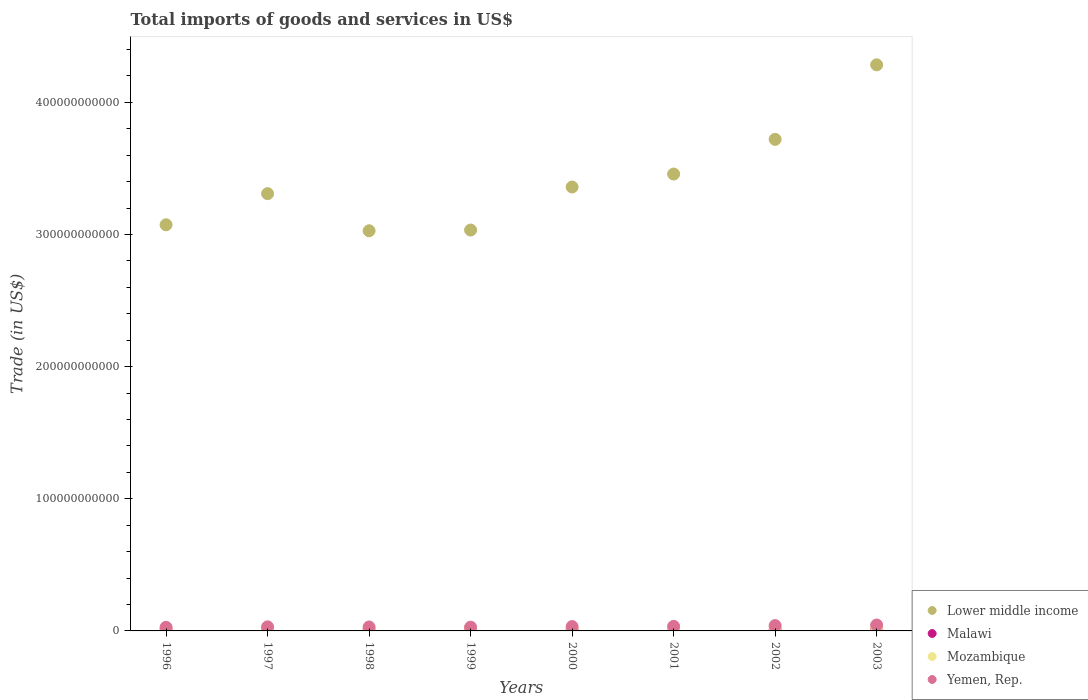Is the number of dotlines equal to the number of legend labels?
Your answer should be compact. Yes. What is the total imports of goods and services in Lower middle income in 1996?
Keep it short and to the point. 3.07e+11. Across all years, what is the maximum total imports of goods and services in Lower middle income?
Keep it short and to the point. 4.28e+11. Across all years, what is the minimum total imports of goods and services in Malawi?
Ensure brevity in your answer.  6.16e+08. In which year was the total imports of goods and services in Lower middle income minimum?
Provide a short and direct response. 1998. What is the total total imports of goods and services in Malawi in the graph?
Your answer should be compact. 6.24e+09. What is the difference between the total imports of goods and services in Mozambique in 1999 and that in 2002?
Your answer should be very brief. -7.22e+08. What is the difference between the total imports of goods and services in Mozambique in 2003 and the total imports of goods and services in Lower middle income in 1999?
Your answer should be very brief. -3.01e+11. What is the average total imports of goods and services in Lower middle income per year?
Give a very brief answer. 3.41e+11. In the year 1999, what is the difference between the total imports of goods and services in Yemen, Rep. and total imports of goods and services in Mozambique?
Keep it short and to the point. 7.44e+08. What is the ratio of the total imports of goods and services in Malawi in 2000 to that in 2001?
Your answer should be compact. 0.92. Is the total imports of goods and services in Yemen, Rep. in 1998 less than that in 2000?
Keep it short and to the point. Yes. What is the difference between the highest and the second highest total imports of goods and services in Mozambique?
Provide a succinct answer. 3.37e+07. What is the difference between the highest and the lowest total imports of goods and services in Malawi?
Provide a short and direct response. 3.68e+08. In how many years, is the total imports of goods and services in Lower middle income greater than the average total imports of goods and services in Lower middle income taken over all years?
Provide a succinct answer. 3. Is it the case that in every year, the sum of the total imports of goods and services in Mozambique and total imports of goods and services in Malawi  is greater than the total imports of goods and services in Lower middle income?
Your answer should be compact. No. Is the total imports of goods and services in Lower middle income strictly greater than the total imports of goods and services in Malawi over the years?
Your response must be concise. Yes. How many years are there in the graph?
Provide a short and direct response. 8. What is the difference between two consecutive major ticks on the Y-axis?
Provide a succinct answer. 1.00e+11. Does the graph contain grids?
Your response must be concise. No. Where does the legend appear in the graph?
Your answer should be compact. Bottom right. How many legend labels are there?
Keep it short and to the point. 4. How are the legend labels stacked?
Make the answer very short. Vertical. What is the title of the graph?
Your answer should be compact. Total imports of goods and services in US$. Does "Madagascar" appear as one of the legend labels in the graph?
Ensure brevity in your answer.  No. What is the label or title of the Y-axis?
Ensure brevity in your answer.  Trade (in US$). What is the Trade (in US$) of Lower middle income in 1996?
Make the answer very short. 3.07e+11. What is the Trade (in US$) of Malawi in 1996?
Keep it short and to the point. 7.27e+08. What is the Trade (in US$) of Mozambique in 1996?
Give a very brief answer. 1.43e+09. What is the Trade (in US$) of Yemen, Rep. in 1996?
Offer a very short reply. 2.74e+09. What is the Trade (in US$) of Lower middle income in 1997?
Offer a terse response. 3.31e+11. What is the Trade (in US$) in Malawi in 1997?
Offer a very short reply. 8.94e+08. What is the Trade (in US$) in Mozambique in 1997?
Your answer should be very brief. 1.44e+09. What is the Trade (in US$) of Yemen, Rep. in 1997?
Provide a succinct answer. 3.08e+09. What is the Trade (in US$) of Lower middle income in 1998?
Keep it short and to the point. 3.03e+11. What is the Trade (in US$) of Malawi in 1998?
Keep it short and to the point. 6.67e+08. What is the Trade (in US$) in Mozambique in 1998?
Your answer should be very brief. 1.47e+09. What is the Trade (in US$) of Yemen, Rep. in 1998?
Your answer should be very brief. 2.98e+09. What is the Trade (in US$) of Lower middle income in 1999?
Your response must be concise. 3.03e+11. What is the Trade (in US$) of Malawi in 1999?
Provide a succinct answer. 7.69e+08. What is the Trade (in US$) in Mozambique in 1999?
Your response must be concise. 2.10e+09. What is the Trade (in US$) in Yemen, Rep. in 1999?
Offer a terse response. 2.84e+09. What is the Trade (in US$) of Lower middle income in 2000?
Keep it short and to the point. 3.36e+11. What is the Trade (in US$) of Malawi in 2000?
Make the answer very short. 6.16e+08. What is the Trade (in US$) in Mozambique in 2000?
Keep it short and to the point. 1.98e+09. What is the Trade (in US$) in Yemen, Rep. in 2000?
Give a very brief answer. 3.28e+09. What is the Trade (in US$) in Lower middle income in 2001?
Offer a terse response. 3.46e+11. What is the Trade (in US$) in Malawi in 2001?
Provide a succinct answer. 6.72e+08. What is the Trade (in US$) in Mozambique in 2001?
Your answer should be compact. 1.64e+09. What is the Trade (in US$) of Yemen, Rep. in 2001?
Offer a very short reply. 3.45e+09. What is the Trade (in US$) of Lower middle income in 2002?
Provide a short and direct response. 3.72e+11. What is the Trade (in US$) of Malawi in 2002?
Ensure brevity in your answer.  9.10e+08. What is the Trade (in US$) of Mozambique in 2002?
Your response must be concise. 2.82e+09. What is the Trade (in US$) in Yemen, Rep. in 2002?
Your answer should be compact. 4.03e+09. What is the Trade (in US$) in Lower middle income in 2003?
Offer a terse response. 4.28e+11. What is the Trade (in US$) in Malawi in 2003?
Offer a very short reply. 9.84e+08. What is the Trade (in US$) in Mozambique in 2003?
Offer a terse response. 2.85e+09. What is the Trade (in US$) in Yemen, Rep. in 2003?
Your answer should be very brief. 4.47e+09. Across all years, what is the maximum Trade (in US$) in Lower middle income?
Your answer should be compact. 4.28e+11. Across all years, what is the maximum Trade (in US$) in Malawi?
Make the answer very short. 9.84e+08. Across all years, what is the maximum Trade (in US$) of Mozambique?
Make the answer very short. 2.85e+09. Across all years, what is the maximum Trade (in US$) of Yemen, Rep.?
Keep it short and to the point. 4.47e+09. Across all years, what is the minimum Trade (in US$) of Lower middle income?
Your response must be concise. 3.03e+11. Across all years, what is the minimum Trade (in US$) in Malawi?
Give a very brief answer. 6.16e+08. Across all years, what is the minimum Trade (in US$) of Mozambique?
Ensure brevity in your answer.  1.43e+09. Across all years, what is the minimum Trade (in US$) of Yemen, Rep.?
Offer a terse response. 2.74e+09. What is the total Trade (in US$) of Lower middle income in the graph?
Your answer should be very brief. 2.73e+12. What is the total Trade (in US$) in Malawi in the graph?
Your response must be concise. 6.24e+09. What is the total Trade (in US$) of Mozambique in the graph?
Provide a succinct answer. 1.57e+1. What is the total Trade (in US$) in Yemen, Rep. in the graph?
Give a very brief answer. 2.69e+1. What is the difference between the Trade (in US$) in Lower middle income in 1996 and that in 1997?
Make the answer very short. -2.36e+1. What is the difference between the Trade (in US$) of Malawi in 1996 and that in 1997?
Provide a succinct answer. -1.67e+08. What is the difference between the Trade (in US$) of Mozambique in 1996 and that in 1997?
Your answer should be very brief. -1.18e+07. What is the difference between the Trade (in US$) in Yemen, Rep. in 1996 and that in 1997?
Make the answer very short. -3.40e+08. What is the difference between the Trade (in US$) of Lower middle income in 1996 and that in 1998?
Offer a terse response. 4.52e+09. What is the difference between the Trade (in US$) of Malawi in 1996 and that in 1998?
Keep it short and to the point. 6.01e+07. What is the difference between the Trade (in US$) of Mozambique in 1996 and that in 1998?
Your answer should be very brief. -4.30e+07. What is the difference between the Trade (in US$) in Yemen, Rep. in 1996 and that in 1998?
Offer a very short reply. -2.39e+08. What is the difference between the Trade (in US$) of Lower middle income in 1996 and that in 1999?
Your answer should be compact. 3.98e+09. What is the difference between the Trade (in US$) of Malawi in 1996 and that in 1999?
Give a very brief answer. -4.17e+07. What is the difference between the Trade (in US$) of Mozambique in 1996 and that in 1999?
Your answer should be compact. -6.67e+08. What is the difference between the Trade (in US$) in Yemen, Rep. in 1996 and that in 1999?
Provide a short and direct response. -9.55e+07. What is the difference between the Trade (in US$) in Lower middle income in 1996 and that in 2000?
Ensure brevity in your answer.  -2.86e+1. What is the difference between the Trade (in US$) of Malawi in 1996 and that in 2000?
Offer a very short reply. 1.11e+08. What is the difference between the Trade (in US$) of Mozambique in 1996 and that in 2000?
Offer a very short reply. -5.56e+08. What is the difference between the Trade (in US$) in Yemen, Rep. in 1996 and that in 2000?
Provide a succinct answer. -5.35e+08. What is the difference between the Trade (in US$) in Lower middle income in 1996 and that in 2001?
Provide a short and direct response. -3.84e+1. What is the difference between the Trade (in US$) in Malawi in 1996 and that in 2001?
Your response must be concise. 5.55e+07. What is the difference between the Trade (in US$) of Mozambique in 1996 and that in 2001?
Your answer should be very brief. -2.06e+08. What is the difference between the Trade (in US$) of Yemen, Rep. in 1996 and that in 2001?
Your answer should be compact. -7.04e+08. What is the difference between the Trade (in US$) of Lower middle income in 1996 and that in 2002?
Keep it short and to the point. -6.47e+1. What is the difference between the Trade (in US$) of Malawi in 1996 and that in 2002?
Provide a short and direct response. -1.83e+08. What is the difference between the Trade (in US$) in Mozambique in 1996 and that in 2002?
Your answer should be very brief. -1.39e+09. What is the difference between the Trade (in US$) in Yemen, Rep. in 1996 and that in 2002?
Your response must be concise. -1.29e+09. What is the difference between the Trade (in US$) in Lower middle income in 1996 and that in 2003?
Offer a terse response. -1.21e+11. What is the difference between the Trade (in US$) of Malawi in 1996 and that in 2003?
Give a very brief answer. -2.57e+08. What is the difference between the Trade (in US$) of Mozambique in 1996 and that in 2003?
Ensure brevity in your answer.  -1.42e+09. What is the difference between the Trade (in US$) of Yemen, Rep. in 1996 and that in 2003?
Provide a succinct answer. -1.72e+09. What is the difference between the Trade (in US$) of Lower middle income in 1997 and that in 1998?
Your answer should be very brief. 2.81e+1. What is the difference between the Trade (in US$) of Malawi in 1997 and that in 1998?
Ensure brevity in your answer.  2.27e+08. What is the difference between the Trade (in US$) of Mozambique in 1997 and that in 1998?
Offer a terse response. -3.12e+07. What is the difference between the Trade (in US$) of Yemen, Rep. in 1997 and that in 1998?
Your response must be concise. 1.01e+08. What is the difference between the Trade (in US$) in Lower middle income in 1997 and that in 1999?
Make the answer very short. 2.75e+1. What is the difference between the Trade (in US$) of Malawi in 1997 and that in 1999?
Your answer should be compact. 1.26e+08. What is the difference between the Trade (in US$) of Mozambique in 1997 and that in 1999?
Provide a short and direct response. -6.55e+08. What is the difference between the Trade (in US$) in Yemen, Rep. in 1997 and that in 1999?
Provide a short and direct response. 2.44e+08. What is the difference between the Trade (in US$) in Lower middle income in 1997 and that in 2000?
Your answer should be very brief. -5.03e+09. What is the difference between the Trade (in US$) in Malawi in 1997 and that in 2000?
Offer a very short reply. 2.78e+08. What is the difference between the Trade (in US$) in Mozambique in 1997 and that in 2000?
Your answer should be compact. -5.44e+08. What is the difference between the Trade (in US$) in Yemen, Rep. in 1997 and that in 2000?
Ensure brevity in your answer.  -1.95e+08. What is the difference between the Trade (in US$) of Lower middle income in 1997 and that in 2001?
Give a very brief answer. -1.49e+1. What is the difference between the Trade (in US$) in Malawi in 1997 and that in 2001?
Offer a very short reply. 2.23e+08. What is the difference between the Trade (in US$) in Mozambique in 1997 and that in 2001?
Your response must be concise. -1.95e+08. What is the difference between the Trade (in US$) of Yemen, Rep. in 1997 and that in 2001?
Your answer should be compact. -3.64e+08. What is the difference between the Trade (in US$) of Lower middle income in 1997 and that in 2002?
Provide a succinct answer. -4.11e+1. What is the difference between the Trade (in US$) of Malawi in 1997 and that in 2002?
Ensure brevity in your answer.  -1.58e+07. What is the difference between the Trade (in US$) in Mozambique in 1997 and that in 2002?
Give a very brief answer. -1.38e+09. What is the difference between the Trade (in US$) in Yemen, Rep. in 1997 and that in 2002?
Give a very brief answer. -9.50e+08. What is the difference between the Trade (in US$) of Lower middle income in 1997 and that in 2003?
Give a very brief answer. -9.75e+1. What is the difference between the Trade (in US$) of Malawi in 1997 and that in 2003?
Ensure brevity in your answer.  -8.99e+07. What is the difference between the Trade (in US$) in Mozambique in 1997 and that in 2003?
Make the answer very short. -1.41e+09. What is the difference between the Trade (in US$) of Yemen, Rep. in 1997 and that in 2003?
Make the answer very short. -1.38e+09. What is the difference between the Trade (in US$) in Lower middle income in 1998 and that in 1999?
Your response must be concise. -5.44e+08. What is the difference between the Trade (in US$) of Malawi in 1998 and that in 1999?
Give a very brief answer. -1.02e+08. What is the difference between the Trade (in US$) of Mozambique in 1998 and that in 1999?
Offer a very short reply. -6.24e+08. What is the difference between the Trade (in US$) in Yemen, Rep. in 1998 and that in 1999?
Ensure brevity in your answer.  1.43e+08. What is the difference between the Trade (in US$) in Lower middle income in 1998 and that in 2000?
Your response must be concise. -3.31e+1. What is the difference between the Trade (in US$) in Malawi in 1998 and that in 2000?
Offer a very short reply. 5.10e+07. What is the difference between the Trade (in US$) of Mozambique in 1998 and that in 2000?
Your response must be concise. -5.13e+08. What is the difference between the Trade (in US$) in Yemen, Rep. in 1998 and that in 2000?
Your answer should be compact. -2.96e+08. What is the difference between the Trade (in US$) of Lower middle income in 1998 and that in 2001?
Provide a short and direct response. -4.29e+1. What is the difference between the Trade (in US$) of Malawi in 1998 and that in 2001?
Offer a terse response. -4.56e+06. What is the difference between the Trade (in US$) of Mozambique in 1998 and that in 2001?
Give a very brief answer. -1.63e+08. What is the difference between the Trade (in US$) of Yemen, Rep. in 1998 and that in 2001?
Offer a very short reply. -4.65e+08. What is the difference between the Trade (in US$) in Lower middle income in 1998 and that in 2002?
Your answer should be compact. -6.92e+1. What is the difference between the Trade (in US$) of Malawi in 1998 and that in 2002?
Provide a short and direct response. -2.43e+08. What is the difference between the Trade (in US$) in Mozambique in 1998 and that in 2002?
Your response must be concise. -1.35e+09. What is the difference between the Trade (in US$) of Yemen, Rep. in 1998 and that in 2002?
Make the answer very short. -1.05e+09. What is the difference between the Trade (in US$) of Lower middle income in 1998 and that in 2003?
Provide a succinct answer. -1.26e+11. What is the difference between the Trade (in US$) in Malawi in 1998 and that in 2003?
Ensure brevity in your answer.  -3.17e+08. What is the difference between the Trade (in US$) in Mozambique in 1998 and that in 2003?
Your answer should be very brief. -1.38e+09. What is the difference between the Trade (in US$) in Yemen, Rep. in 1998 and that in 2003?
Your response must be concise. -1.49e+09. What is the difference between the Trade (in US$) in Lower middle income in 1999 and that in 2000?
Make the answer very short. -3.26e+1. What is the difference between the Trade (in US$) in Malawi in 1999 and that in 2000?
Your answer should be very brief. 1.53e+08. What is the difference between the Trade (in US$) of Mozambique in 1999 and that in 2000?
Ensure brevity in your answer.  1.11e+08. What is the difference between the Trade (in US$) in Yemen, Rep. in 1999 and that in 2000?
Offer a very short reply. -4.39e+08. What is the difference between the Trade (in US$) of Lower middle income in 1999 and that in 2001?
Your answer should be compact. -4.24e+1. What is the difference between the Trade (in US$) in Malawi in 1999 and that in 2001?
Make the answer very short. 9.72e+07. What is the difference between the Trade (in US$) of Mozambique in 1999 and that in 2001?
Offer a very short reply. 4.60e+08. What is the difference between the Trade (in US$) of Yemen, Rep. in 1999 and that in 2001?
Provide a short and direct response. -6.09e+08. What is the difference between the Trade (in US$) in Lower middle income in 1999 and that in 2002?
Provide a short and direct response. -6.86e+1. What is the difference between the Trade (in US$) of Malawi in 1999 and that in 2002?
Make the answer very short. -1.41e+08. What is the difference between the Trade (in US$) in Mozambique in 1999 and that in 2002?
Give a very brief answer. -7.22e+08. What is the difference between the Trade (in US$) in Yemen, Rep. in 1999 and that in 2002?
Your answer should be compact. -1.19e+09. What is the difference between the Trade (in US$) of Lower middle income in 1999 and that in 2003?
Make the answer very short. -1.25e+11. What is the difference between the Trade (in US$) in Malawi in 1999 and that in 2003?
Your answer should be compact. -2.15e+08. What is the difference between the Trade (in US$) of Mozambique in 1999 and that in 2003?
Provide a short and direct response. -7.56e+08. What is the difference between the Trade (in US$) of Yemen, Rep. in 1999 and that in 2003?
Provide a succinct answer. -1.63e+09. What is the difference between the Trade (in US$) in Lower middle income in 2000 and that in 2001?
Your answer should be compact. -9.82e+09. What is the difference between the Trade (in US$) of Malawi in 2000 and that in 2001?
Offer a terse response. -5.56e+07. What is the difference between the Trade (in US$) in Mozambique in 2000 and that in 2001?
Make the answer very short. 3.50e+08. What is the difference between the Trade (in US$) of Yemen, Rep. in 2000 and that in 2001?
Your answer should be compact. -1.69e+08. What is the difference between the Trade (in US$) in Lower middle income in 2000 and that in 2002?
Give a very brief answer. -3.61e+1. What is the difference between the Trade (in US$) of Malawi in 2000 and that in 2002?
Provide a succinct answer. -2.94e+08. What is the difference between the Trade (in US$) in Mozambique in 2000 and that in 2002?
Your answer should be compact. -8.33e+08. What is the difference between the Trade (in US$) of Yemen, Rep. in 2000 and that in 2002?
Provide a short and direct response. -7.55e+08. What is the difference between the Trade (in US$) of Lower middle income in 2000 and that in 2003?
Offer a terse response. -9.25e+1. What is the difference between the Trade (in US$) in Malawi in 2000 and that in 2003?
Make the answer very short. -3.68e+08. What is the difference between the Trade (in US$) of Mozambique in 2000 and that in 2003?
Provide a succinct answer. -8.67e+08. What is the difference between the Trade (in US$) of Yemen, Rep. in 2000 and that in 2003?
Make the answer very short. -1.19e+09. What is the difference between the Trade (in US$) in Lower middle income in 2001 and that in 2002?
Offer a terse response. -2.62e+1. What is the difference between the Trade (in US$) in Malawi in 2001 and that in 2002?
Your response must be concise. -2.39e+08. What is the difference between the Trade (in US$) of Mozambique in 2001 and that in 2002?
Offer a very short reply. -1.18e+09. What is the difference between the Trade (in US$) in Yemen, Rep. in 2001 and that in 2002?
Your answer should be compact. -5.86e+08. What is the difference between the Trade (in US$) of Lower middle income in 2001 and that in 2003?
Provide a short and direct response. -8.26e+1. What is the difference between the Trade (in US$) of Malawi in 2001 and that in 2003?
Keep it short and to the point. -3.13e+08. What is the difference between the Trade (in US$) in Mozambique in 2001 and that in 2003?
Offer a terse response. -1.22e+09. What is the difference between the Trade (in US$) in Yemen, Rep. in 2001 and that in 2003?
Your response must be concise. -1.02e+09. What is the difference between the Trade (in US$) in Lower middle income in 2002 and that in 2003?
Make the answer very short. -5.64e+1. What is the difference between the Trade (in US$) of Malawi in 2002 and that in 2003?
Offer a very short reply. -7.41e+07. What is the difference between the Trade (in US$) in Mozambique in 2002 and that in 2003?
Give a very brief answer. -3.37e+07. What is the difference between the Trade (in US$) in Yemen, Rep. in 2002 and that in 2003?
Give a very brief answer. -4.34e+08. What is the difference between the Trade (in US$) in Lower middle income in 1996 and the Trade (in US$) in Malawi in 1997?
Offer a terse response. 3.06e+11. What is the difference between the Trade (in US$) in Lower middle income in 1996 and the Trade (in US$) in Mozambique in 1997?
Your answer should be very brief. 3.06e+11. What is the difference between the Trade (in US$) of Lower middle income in 1996 and the Trade (in US$) of Yemen, Rep. in 1997?
Give a very brief answer. 3.04e+11. What is the difference between the Trade (in US$) of Malawi in 1996 and the Trade (in US$) of Mozambique in 1997?
Keep it short and to the point. -7.13e+08. What is the difference between the Trade (in US$) of Malawi in 1996 and the Trade (in US$) of Yemen, Rep. in 1997?
Provide a succinct answer. -2.36e+09. What is the difference between the Trade (in US$) of Mozambique in 1996 and the Trade (in US$) of Yemen, Rep. in 1997?
Make the answer very short. -1.66e+09. What is the difference between the Trade (in US$) in Lower middle income in 1996 and the Trade (in US$) in Malawi in 1998?
Your answer should be very brief. 3.07e+11. What is the difference between the Trade (in US$) of Lower middle income in 1996 and the Trade (in US$) of Mozambique in 1998?
Your answer should be very brief. 3.06e+11. What is the difference between the Trade (in US$) in Lower middle income in 1996 and the Trade (in US$) in Yemen, Rep. in 1998?
Ensure brevity in your answer.  3.04e+11. What is the difference between the Trade (in US$) in Malawi in 1996 and the Trade (in US$) in Mozambique in 1998?
Your response must be concise. -7.45e+08. What is the difference between the Trade (in US$) of Malawi in 1996 and the Trade (in US$) of Yemen, Rep. in 1998?
Your response must be concise. -2.26e+09. What is the difference between the Trade (in US$) in Mozambique in 1996 and the Trade (in US$) in Yemen, Rep. in 1998?
Make the answer very short. -1.55e+09. What is the difference between the Trade (in US$) of Lower middle income in 1996 and the Trade (in US$) of Malawi in 1999?
Provide a short and direct response. 3.07e+11. What is the difference between the Trade (in US$) in Lower middle income in 1996 and the Trade (in US$) in Mozambique in 1999?
Provide a succinct answer. 3.05e+11. What is the difference between the Trade (in US$) in Lower middle income in 1996 and the Trade (in US$) in Yemen, Rep. in 1999?
Make the answer very short. 3.05e+11. What is the difference between the Trade (in US$) in Malawi in 1996 and the Trade (in US$) in Mozambique in 1999?
Ensure brevity in your answer.  -1.37e+09. What is the difference between the Trade (in US$) of Malawi in 1996 and the Trade (in US$) of Yemen, Rep. in 1999?
Offer a terse response. -2.11e+09. What is the difference between the Trade (in US$) in Mozambique in 1996 and the Trade (in US$) in Yemen, Rep. in 1999?
Offer a terse response. -1.41e+09. What is the difference between the Trade (in US$) in Lower middle income in 1996 and the Trade (in US$) in Malawi in 2000?
Make the answer very short. 3.07e+11. What is the difference between the Trade (in US$) of Lower middle income in 1996 and the Trade (in US$) of Mozambique in 2000?
Offer a very short reply. 3.05e+11. What is the difference between the Trade (in US$) of Lower middle income in 1996 and the Trade (in US$) of Yemen, Rep. in 2000?
Your answer should be very brief. 3.04e+11. What is the difference between the Trade (in US$) in Malawi in 1996 and the Trade (in US$) in Mozambique in 2000?
Give a very brief answer. -1.26e+09. What is the difference between the Trade (in US$) of Malawi in 1996 and the Trade (in US$) of Yemen, Rep. in 2000?
Offer a very short reply. -2.55e+09. What is the difference between the Trade (in US$) in Mozambique in 1996 and the Trade (in US$) in Yemen, Rep. in 2000?
Your response must be concise. -1.85e+09. What is the difference between the Trade (in US$) in Lower middle income in 1996 and the Trade (in US$) in Malawi in 2001?
Your response must be concise. 3.07e+11. What is the difference between the Trade (in US$) of Lower middle income in 1996 and the Trade (in US$) of Mozambique in 2001?
Ensure brevity in your answer.  3.06e+11. What is the difference between the Trade (in US$) in Lower middle income in 1996 and the Trade (in US$) in Yemen, Rep. in 2001?
Your answer should be very brief. 3.04e+11. What is the difference between the Trade (in US$) of Malawi in 1996 and the Trade (in US$) of Mozambique in 2001?
Provide a short and direct response. -9.08e+08. What is the difference between the Trade (in US$) in Malawi in 1996 and the Trade (in US$) in Yemen, Rep. in 2001?
Keep it short and to the point. -2.72e+09. What is the difference between the Trade (in US$) in Mozambique in 1996 and the Trade (in US$) in Yemen, Rep. in 2001?
Your answer should be very brief. -2.02e+09. What is the difference between the Trade (in US$) in Lower middle income in 1996 and the Trade (in US$) in Malawi in 2002?
Your response must be concise. 3.06e+11. What is the difference between the Trade (in US$) in Lower middle income in 1996 and the Trade (in US$) in Mozambique in 2002?
Your answer should be very brief. 3.05e+11. What is the difference between the Trade (in US$) of Lower middle income in 1996 and the Trade (in US$) of Yemen, Rep. in 2002?
Offer a very short reply. 3.03e+11. What is the difference between the Trade (in US$) in Malawi in 1996 and the Trade (in US$) in Mozambique in 2002?
Ensure brevity in your answer.  -2.09e+09. What is the difference between the Trade (in US$) in Malawi in 1996 and the Trade (in US$) in Yemen, Rep. in 2002?
Offer a terse response. -3.31e+09. What is the difference between the Trade (in US$) of Mozambique in 1996 and the Trade (in US$) of Yemen, Rep. in 2002?
Offer a terse response. -2.61e+09. What is the difference between the Trade (in US$) in Lower middle income in 1996 and the Trade (in US$) in Malawi in 2003?
Your answer should be very brief. 3.06e+11. What is the difference between the Trade (in US$) in Lower middle income in 1996 and the Trade (in US$) in Mozambique in 2003?
Your answer should be very brief. 3.04e+11. What is the difference between the Trade (in US$) in Lower middle income in 1996 and the Trade (in US$) in Yemen, Rep. in 2003?
Give a very brief answer. 3.03e+11. What is the difference between the Trade (in US$) of Malawi in 1996 and the Trade (in US$) of Mozambique in 2003?
Offer a terse response. -2.12e+09. What is the difference between the Trade (in US$) in Malawi in 1996 and the Trade (in US$) in Yemen, Rep. in 2003?
Provide a short and direct response. -3.74e+09. What is the difference between the Trade (in US$) of Mozambique in 1996 and the Trade (in US$) of Yemen, Rep. in 2003?
Make the answer very short. -3.04e+09. What is the difference between the Trade (in US$) of Lower middle income in 1997 and the Trade (in US$) of Malawi in 1998?
Offer a very short reply. 3.30e+11. What is the difference between the Trade (in US$) in Lower middle income in 1997 and the Trade (in US$) in Mozambique in 1998?
Your answer should be very brief. 3.29e+11. What is the difference between the Trade (in US$) of Lower middle income in 1997 and the Trade (in US$) of Yemen, Rep. in 1998?
Your response must be concise. 3.28e+11. What is the difference between the Trade (in US$) in Malawi in 1997 and the Trade (in US$) in Mozambique in 1998?
Give a very brief answer. -5.77e+08. What is the difference between the Trade (in US$) in Malawi in 1997 and the Trade (in US$) in Yemen, Rep. in 1998?
Keep it short and to the point. -2.09e+09. What is the difference between the Trade (in US$) of Mozambique in 1997 and the Trade (in US$) of Yemen, Rep. in 1998?
Your response must be concise. -1.54e+09. What is the difference between the Trade (in US$) of Lower middle income in 1997 and the Trade (in US$) of Malawi in 1999?
Keep it short and to the point. 3.30e+11. What is the difference between the Trade (in US$) of Lower middle income in 1997 and the Trade (in US$) of Mozambique in 1999?
Provide a short and direct response. 3.29e+11. What is the difference between the Trade (in US$) in Lower middle income in 1997 and the Trade (in US$) in Yemen, Rep. in 1999?
Offer a very short reply. 3.28e+11. What is the difference between the Trade (in US$) of Malawi in 1997 and the Trade (in US$) of Mozambique in 1999?
Offer a very short reply. -1.20e+09. What is the difference between the Trade (in US$) of Malawi in 1997 and the Trade (in US$) of Yemen, Rep. in 1999?
Offer a very short reply. -1.95e+09. What is the difference between the Trade (in US$) in Mozambique in 1997 and the Trade (in US$) in Yemen, Rep. in 1999?
Your answer should be compact. -1.40e+09. What is the difference between the Trade (in US$) of Lower middle income in 1997 and the Trade (in US$) of Malawi in 2000?
Keep it short and to the point. 3.30e+11. What is the difference between the Trade (in US$) in Lower middle income in 1997 and the Trade (in US$) in Mozambique in 2000?
Your answer should be compact. 3.29e+11. What is the difference between the Trade (in US$) in Lower middle income in 1997 and the Trade (in US$) in Yemen, Rep. in 2000?
Offer a very short reply. 3.28e+11. What is the difference between the Trade (in US$) of Malawi in 1997 and the Trade (in US$) of Mozambique in 2000?
Your answer should be very brief. -1.09e+09. What is the difference between the Trade (in US$) of Malawi in 1997 and the Trade (in US$) of Yemen, Rep. in 2000?
Offer a terse response. -2.38e+09. What is the difference between the Trade (in US$) in Mozambique in 1997 and the Trade (in US$) in Yemen, Rep. in 2000?
Give a very brief answer. -1.84e+09. What is the difference between the Trade (in US$) of Lower middle income in 1997 and the Trade (in US$) of Malawi in 2001?
Your answer should be very brief. 3.30e+11. What is the difference between the Trade (in US$) of Lower middle income in 1997 and the Trade (in US$) of Mozambique in 2001?
Make the answer very short. 3.29e+11. What is the difference between the Trade (in US$) in Lower middle income in 1997 and the Trade (in US$) in Yemen, Rep. in 2001?
Your answer should be very brief. 3.27e+11. What is the difference between the Trade (in US$) in Malawi in 1997 and the Trade (in US$) in Mozambique in 2001?
Provide a short and direct response. -7.41e+08. What is the difference between the Trade (in US$) in Malawi in 1997 and the Trade (in US$) in Yemen, Rep. in 2001?
Your response must be concise. -2.55e+09. What is the difference between the Trade (in US$) of Mozambique in 1997 and the Trade (in US$) of Yemen, Rep. in 2001?
Provide a succinct answer. -2.01e+09. What is the difference between the Trade (in US$) in Lower middle income in 1997 and the Trade (in US$) in Malawi in 2002?
Provide a succinct answer. 3.30e+11. What is the difference between the Trade (in US$) of Lower middle income in 1997 and the Trade (in US$) of Mozambique in 2002?
Make the answer very short. 3.28e+11. What is the difference between the Trade (in US$) in Lower middle income in 1997 and the Trade (in US$) in Yemen, Rep. in 2002?
Give a very brief answer. 3.27e+11. What is the difference between the Trade (in US$) in Malawi in 1997 and the Trade (in US$) in Mozambique in 2002?
Keep it short and to the point. -1.92e+09. What is the difference between the Trade (in US$) of Malawi in 1997 and the Trade (in US$) of Yemen, Rep. in 2002?
Your response must be concise. -3.14e+09. What is the difference between the Trade (in US$) in Mozambique in 1997 and the Trade (in US$) in Yemen, Rep. in 2002?
Make the answer very short. -2.59e+09. What is the difference between the Trade (in US$) in Lower middle income in 1997 and the Trade (in US$) in Malawi in 2003?
Provide a succinct answer. 3.30e+11. What is the difference between the Trade (in US$) in Lower middle income in 1997 and the Trade (in US$) in Mozambique in 2003?
Ensure brevity in your answer.  3.28e+11. What is the difference between the Trade (in US$) in Lower middle income in 1997 and the Trade (in US$) in Yemen, Rep. in 2003?
Provide a short and direct response. 3.26e+11. What is the difference between the Trade (in US$) in Malawi in 1997 and the Trade (in US$) in Mozambique in 2003?
Offer a terse response. -1.96e+09. What is the difference between the Trade (in US$) in Malawi in 1997 and the Trade (in US$) in Yemen, Rep. in 2003?
Ensure brevity in your answer.  -3.57e+09. What is the difference between the Trade (in US$) in Mozambique in 1997 and the Trade (in US$) in Yemen, Rep. in 2003?
Give a very brief answer. -3.03e+09. What is the difference between the Trade (in US$) of Lower middle income in 1998 and the Trade (in US$) of Malawi in 1999?
Offer a very short reply. 3.02e+11. What is the difference between the Trade (in US$) in Lower middle income in 1998 and the Trade (in US$) in Mozambique in 1999?
Keep it short and to the point. 3.01e+11. What is the difference between the Trade (in US$) in Lower middle income in 1998 and the Trade (in US$) in Yemen, Rep. in 1999?
Ensure brevity in your answer.  3.00e+11. What is the difference between the Trade (in US$) in Malawi in 1998 and the Trade (in US$) in Mozambique in 1999?
Keep it short and to the point. -1.43e+09. What is the difference between the Trade (in US$) of Malawi in 1998 and the Trade (in US$) of Yemen, Rep. in 1999?
Offer a terse response. -2.17e+09. What is the difference between the Trade (in US$) of Mozambique in 1998 and the Trade (in US$) of Yemen, Rep. in 1999?
Your response must be concise. -1.37e+09. What is the difference between the Trade (in US$) in Lower middle income in 1998 and the Trade (in US$) in Malawi in 2000?
Provide a succinct answer. 3.02e+11. What is the difference between the Trade (in US$) of Lower middle income in 1998 and the Trade (in US$) of Mozambique in 2000?
Make the answer very short. 3.01e+11. What is the difference between the Trade (in US$) of Lower middle income in 1998 and the Trade (in US$) of Yemen, Rep. in 2000?
Your response must be concise. 3.00e+11. What is the difference between the Trade (in US$) in Malawi in 1998 and the Trade (in US$) in Mozambique in 2000?
Your answer should be very brief. -1.32e+09. What is the difference between the Trade (in US$) in Malawi in 1998 and the Trade (in US$) in Yemen, Rep. in 2000?
Your answer should be very brief. -2.61e+09. What is the difference between the Trade (in US$) in Mozambique in 1998 and the Trade (in US$) in Yemen, Rep. in 2000?
Offer a very short reply. -1.81e+09. What is the difference between the Trade (in US$) in Lower middle income in 1998 and the Trade (in US$) in Malawi in 2001?
Your response must be concise. 3.02e+11. What is the difference between the Trade (in US$) of Lower middle income in 1998 and the Trade (in US$) of Mozambique in 2001?
Offer a terse response. 3.01e+11. What is the difference between the Trade (in US$) of Lower middle income in 1998 and the Trade (in US$) of Yemen, Rep. in 2001?
Provide a short and direct response. 2.99e+11. What is the difference between the Trade (in US$) in Malawi in 1998 and the Trade (in US$) in Mozambique in 2001?
Provide a short and direct response. -9.68e+08. What is the difference between the Trade (in US$) in Malawi in 1998 and the Trade (in US$) in Yemen, Rep. in 2001?
Your answer should be compact. -2.78e+09. What is the difference between the Trade (in US$) in Mozambique in 1998 and the Trade (in US$) in Yemen, Rep. in 2001?
Provide a short and direct response. -1.98e+09. What is the difference between the Trade (in US$) of Lower middle income in 1998 and the Trade (in US$) of Malawi in 2002?
Offer a very short reply. 3.02e+11. What is the difference between the Trade (in US$) of Lower middle income in 1998 and the Trade (in US$) of Mozambique in 2002?
Your response must be concise. 3.00e+11. What is the difference between the Trade (in US$) of Lower middle income in 1998 and the Trade (in US$) of Yemen, Rep. in 2002?
Make the answer very short. 2.99e+11. What is the difference between the Trade (in US$) in Malawi in 1998 and the Trade (in US$) in Mozambique in 2002?
Provide a short and direct response. -2.15e+09. What is the difference between the Trade (in US$) in Malawi in 1998 and the Trade (in US$) in Yemen, Rep. in 2002?
Offer a very short reply. -3.37e+09. What is the difference between the Trade (in US$) of Mozambique in 1998 and the Trade (in US$) of Yemen, Rep. in 2002?
Your answer should be compact. -2.56e+09. What is the difference between the Trade (in US$) in Lower middle income in 1998 and the Trade (in US$) in Malawi in 2003?
Keep it short and to the point. 3.02e+11. What is the difference between the Trade (in US$) in Lower middle income in 1998 and the Trade (in US$) in Mozambique in 2003?
Your response must be concise. 3.00e+11. What is the difference between the Trade (in US$) of Lower middle income in 1998 and the Trade (in US$) of Yemen, Rep. in 2003?
Your answer should be very brief. 2.98e+11. What is the difference between the Trade (in US$) in Malawi in 1998 and the Trade (in US$) in Mozambique in 2003?
Ensure brevity in your answer.  -2.18e+09. What is the difference between the Trade (in US$) in Malawi in 1998 and the Trade (in US$) in Yemen, Rep. in 2003?
Provide a short and direct response. -3.80e+09. What is the difference between the Trade (in US$) in Mozambique in 1998 and the Trade (in US$) in Yemen, Rep. in 2003?
Keep it short and to the point. -3.00e+09. What is the difference between the Trade (in US$) of Lower middle income in 1999 and the Trade (in US$) of Malawi in 2000?
Give a very brief answer. 3.03e+11. What is the difference between the Trade (in US$) in Lower middle income in 1999 and the Trade (in US$) in Mozambique in 2000?
Your answer should be compact. 3.01e+11. What is the difference between the Trade (in US$) of Lower middle income in 1999 and the Trade (in US$) of Yemen, Rep. in 2000?
Your answer should be very brief. 3.00e+11. What is the difference between the Trade (in US$) in Malawi in 1999 and the Trade (in US$) in Mozambique in 2000?
Provide a succinct answer. -1.22e+09. What is the difference between the Trade (in US$) of Malawi in 1999 and the Trade (in US$) of Yemen, Rep. in 2000?
Ensure brevity in your answer.  -2.51e+09. What is the difference between the Trade (in US$) in Mozambique in 1999 and the Trade (in US$) in Yemen, Rep. in 2000?
Your answer should be very brief. -1.18e+09. What is the difference between the Trade (in US$) of Lower middle income in 1999 and the Trade (in US$) of Malawi in 2001?
Your answer should be very brief. 3.03e+11. What is the difference between the Trade (in US$) in Lower middle income in 1999 and the Trade (in US$) in Mozambique in 2001?
Your answer should be very brief. 3.02e+11. What is the difference between the Trade (in US$) of Lower middle income in 1999 and the Trade (in US$) of Yemen, Rep. in 2001?
Make the answer very short. 3.00e+11. What is the difference between the Trade (in US$) of Malawi in 1999 and the Trade (in US$) of Mozambique in 2001?
Provide a succinct answer. -8.66e+08. What is the difference between the Trade (in US$) of Malawi in 1999 and the Trade (in US$) of Yemen, Rep. in 2001?
Offer a very short reply. -2.68e+09. What is the difference between the Trade (in US$) in Mozambique in 1999 and the Trade (in US$) in Yemen, Rep. in 2001?
Make the answer very short. -1.35e+09. What is the difference between the Trade (in US$) in Lower middle income in 1999 and the Trade (in US$) in Malawi in 2002?
Offer a terse response. 3.02e+11. What is the difference between the Trade (in US$) of Lower middle income in 1999 and the Trade (in US$) of Mozambique in 2002?
Provide a short and direct response. 3.01e+11. What is the difference between the Trade (in US$) of Lower middle income in 1999 and the Trade (in US$) of Yemen, Rep. in 2002?
Your answer should be compact. 2.99e+11. What is the difference between the Trade (in US$) in Malawi in 1999 and the Trade (in US$) in Mozambique in 2002?
Your answer should be compact. -2.05e+09. What is the difference between the Trade (in US$) of Malawi in 1999 and the Trade (in US$) of Yemen, Rep. in 2002?
Your answer should be compact. -3.27e+09. What is the difference between the Trade (in US$) in Mozambique in 1999 and the Trade (in US$) in Yemen, Rep. in 2002?
Provide a short and direct response. -1.94e+09. What is the difference between the Trade (in US$) of Lower middle income in 1999 and the Trade (in US$) of Malawi in 2003?
Keep it short and to the point. 3.02e+11. What is the difference between the Trade (in US$) in Lower middle income in 1999 and the Trade (in US$) in Mozambique in 2003?
Offer a very short reply. 3.01e+11. What is the difference between the Trade (in US$) in Lower middle income in 1999 and the Trade (in US$) in Yemen, Rep. in 2003?
Make the answer very short. 2.99e+11. What is the difference between the Trade (in US$) in Malawi in 1999 and the Trade (in US$) in Mozambique in 2003?
Offer a terse response. -2.08e+09. What is the difference between the Trade (in US$) of Malawi in 1999 and the Trade (in US$) of Yemen, Rep. in 2003?
Make the answer very short. -3.70e+09. What is the difference between the Trade (in US$) in Mozambique in 1999 and the Trade (in US$) in Yemen, Rep. in 2003?
Your response must be concise. -2.37e+09. What is the difference between the Trade (in US$) of Lower middle income in 2000 and the Trade (in US$) of Malawi in 2001?
Your response must be concise. 3.35e+11. What is the difference between the Trade (in US$) of Lower middle income in 2000 and the Trade (in US$) of Mozambique in 2001?
Your response must be concise. 3.34e+11. What is the difference between the Trade (in US$) of Lower middle income in 2000 and the Trade (in US$) of Yemen, Rep. in 2001?
Ensure brevity in your answer.  3.32e+11. What is the difference between the Trade (in US$) of Malawi in 2000 and the Trade (in US$) of Mozambique in 2001?
Provide a succinct answer. -1.02e+09. What is the difference between the Trade (in US$) in Malawi in 2000 and the Trade (in US$) in Yemen, Rep. in 2001?
Your answer should be compact. -2.83e+09. What is the difference between the Trade (in US$) in Mozambique in 2000 and the Trade (in US$) in Yemen, Rep. in 2001?
Your answer should be compact. -1.46e+09. What is the difference between the Trade (in US$) in Lower middle income in 2000 and the Trade (in US$) in Malawi in 2002?
Provide a short and direct response. 3.35e+11. What is the difference between the Trade (in US$) in Lower middle income in 2000 and the Trade (in US$) in Mozambique in 2002?
Keep it short and to the point. 3.33e+11. What is the difference between the Trade (in US$) in Lower middle income in 2000 and the Trade (in US$) in Yemen, Rep. in 2002?
Offer a very short reply. 3.32e+11. What is the difference between the Trade (in US$) of Malawi in 2000 and the Trade (in US$) of Mozambique in 2002?
Provide a succinct answer. -2.20e+09. What is the difference between the Trade (in US$) in Malawi in 2000 and the Trade (in US$) in Yemen, Rep. in 2002?
Your answer should be very brief. -3.42e+09. What is the difference between the Trade (in US$) in Mozambique in 2000 and the Trade (in US$) in Yemen, Rep. in 2002?
Provide a succinct answer. -2.05e+09. What is the difference between the Trade (in US$) in Lower middle income in 2000 and the Trade (in US$) in Malawi in 2003?
Make the answer very short. 3.35e+11. What is the difference between the Trade (in US$) in Lower middle income in 2000 and the Trade (in US$) in Mozambique in 2003?
Keep it short and to the point. 3.33e+11. What is the difference between the Trade (in US$) of Lower middle income in 2000 and the Trade (in US$) of Yemen, Rep. in 2003?
Your answer should be very brief. 3.31e+11. What is the difference between the Trade (in US$) of Malawi in 2000 and the Trade (in US$) of Mozambique in 2003?
Your response must be concise. -2.24e+09. What is the difference between the Trade (in US$) of Malawi in 2000 and the Trade (in US$) of Yemen, Rep. in 2003?
Ensure brevity in your answer.  -3.85e+09. What is the difference between the Trade (in US$) of Mozambique in 2000 and the Trade (in US$) of Yemen, Rep. in 2003?
Give a very brief answer. -2.48e+09. What is the difference between the Trade (in US$) of Lower middle income in 2001 and the Trade (in US$) of Malawi in 2002?
Give a very brief answer. 3.45e+11. What is the difference between the Trade (in US$) in Lower middle income in 2001 and the Trade (in US$) in Mozambique in 2002?
Give a very brief answer. 3.43e+11. What is the difference between the Trade (in US$) of Lower middle income in 2001 and the Trade (in US$) of Yemen, Rep. in 2002?
Your answer should be very brief. 3.42e+11. What is the difference between the Trade (in US$) in Malawi in 2001 and the Trade (in US$) in Mozambique in 2002?
Your answer should be very brief. -2.15e+09. What is the difference between the Trade (in US$) of Malawi in 2001 and the Trade (in US$) of Yemen, Rep. in 2002?
Make the answer very short. -3.36e+09. What is the difference between the Trade (in US$) of Mozambique in 2001 and the Trade (in US$) of Yemen, Rep. in 2002?
Provide a short and direct response. -2.40e+09. What is the difference between the Trade (in US$) in Lower middle income in 2001 and the Trade (in US$) in Malawi in 2003?
Your response must be concise. 3.45e+11. What is the difference between the Trade (in US$) in Lower middle income in 2001 and the Trade (in US$) in Mozambique in 2003?
Ensure brevity in your answer.  3.43e+11. What is the difference between the Trade (in US$) in Lower middle income in 2001 and the Trade (in US$) in Yemen, Rep. in 2003?
Offer a very short reply. 3.41e+11. What is the difference between the Trade (in US$) of Malawi in 2001 and the Trade (in US$) of Mozambique in 2003?
Provide a succinct answer. -2.18e+09. What is the difference between the Trade (in US$) in Malawi in 2001 and the Trade (in US$) in Yemen, Rep. in 2003?
Keep it short and to the point. -3.80e+09. What is the difference between the Trade (in US$) in Mozambique in 2001 and the Trade (in US$) in Yemen, Rep. in 2003?
Your response must be concise. -2.83e+09. What is the difference between the Trade (in US$) of Lower middle income in 2002 and the Trade (in US$) of Malawi in 2003?
Ensure brevity in your answer.  3.71e+11. What is the difference between the Trade (in US$) in Lower middle income in 2002 and the Trade (in US$) in Mozambique in 2003?
Keep it short and to the point. 3.69e+11. What is the difference between the Trade (in US$) in Lower middle income in 2002 and the Trade (in US$) in Yemen, Rep. in 2003?
Your answer should be very brief. 3.68e+11. What is the difference between the Trade (in US$) of Malawi in 2002 and the Trade (in US$) of Mozambique in 2003?
Your response must be concise. -1.94e+09. What is the difference between the Trade (in US$) of Malawi in 2002 and the Trade (in US$) of Yemen, Rep. in 2003?
Make the answer very short. -3.56e+09. What is the difference between the Trade (in US$) of Mozambique in 2002 and the Trade (in US$) of Yemen, Rep. in 2003?
Give a very brief answer. -1.65e+09. What is the average Trade (in US$) in Lower middle income per year?
Ensure brevity in your answer.  3.41e+11. What is the average Trade (in US$) of Malawi per year?
Offer a very short reply. 7.80e+08. What is the average Trade (in US$) in Mozambique per year?
Your answer should be very brief. 1.97e+09. What is the average Trade (in US$) of Yemen, Rep. per year?
Your response must be concise. 3.36e+09. In the year 1996, what is the difference between the Trade (in US$) of Lower middle income and Trade (in US$) of Malawi?
Provide a succinct answer. 3.07e+11. In the year 1996, what is the difference between the Trade (in US$) of Lower middle income and Trade (in US$) of Mozambique?
Your response must be concise. 3.06e+11. In the year 1996, what is the difference between the Trade (in US$) of Lower middle income and Trade (in US$) of Yemen, Rep.?
Ensure brevity in your answer.  3.05e+11. In the year 1996, what is the difference between the Trade (in US$) in Malawi and Trade (in US$) in Mozambique?
Offer a very short reply. -7.02e+08. In the year 1996, what is the difference between the Trade (in US$) in Malawi and Trade (in US$) in Yemen, Rep.?
Offer a terse response. -2.02e+09. In the year 1996, what is the difference between the Trade (in US$) of Mozambique and Trade (in US$) of Yemen, Rep.?
Provide a succinct answer. -1.32e+09. In the year 1997, what is the difference between the Trade (in US$) in Lower middle income and Trade (in US$) in Malawi?
Make the answer very short. 3.30e+11. In the year 1997, what is the difference between the Trade (in US$) in Lower middle income and Trade (in US$) in Mozambique?
Your answer should be compact. 3.29e+11. In the year 1997, what is the difference between the Trade (in US$) of Lower middle income and Trade (in US$) of Yemen, Rep.?
Your answer should be very brief. 3.28e+11. In the year 1997, what is the difference between the Trade (in US$) of Malawi and Trade (in US$) of Mozambique?
Offer a terse response. -5.46e+08. In the year 1997, what is the difference between the Trade (in US$) in Malawi and Trade (in US$) in Yemen, Rep.?
Offer a very short reply. -2.19e+09. In the year 1997, what is the difference between the Trade (in US$) in Mozambique and Trade (in US$) in Yemen, Rep.?
Keep it short and to the point. -1.64e+09. In the year 1998, what is the difference between the Trade (in US$) in Lower middle income and Trade (in US$) in Malawi?
Your answer should be very brief. 3.02e+11. In the year 1998, what is the difference between the Trade (in US$) in Lower middle income and Trade (in US$) in Mozambique?
Provide a succinct answer. 3.01e+11. In the year 1998, what is the difference between the Trade (in US$) in Lower middle income and Trade (in US$) in Yemen, Rep.?
Your answer should be compact. 3.00e+11. In the year 1998, what is the difference between the Trade (in US$) of Malawi and Trade (in US$) of Mozambique?
Make the answer very short. -8.05e+08. In the year 1998, what is the difference between the Trade (in US$) of Malawi and Trade (in US$) of Yemen, Rep.?
Make the answer very short. -2.32e+09. In the year 1998, what is the difference between the Trade (in US$) in Mozambique and Trade (in US$) in Yemen, Rep.?
Your response must be concise. -1.51e+09. In the year 1999, what is the difference between the Trade (in US$) of Lower middle income and Trade (in US$) of Malawi?
Your answer should be very brief. 3.03e+11. In the year 1999, what is the difference between the Trade (in US$) of Lower middle income and Trade (in US$) of Mozambique?
Make the answer very short. 3.01e+11. In the year 1999, what is the difference between the Trade (in US$) of Lower middle income and Trade (in US$) of Yemen, Rep.?
Ensure brevity in your answer.  3.01e+11. In the year 1999, what is the difference between the Trade (in US$) in Malawi and Trade (in US$) in Mozambique?
Provide a succinct answer. -1.33e+09. In the year 1999, what is the difference between the Trade (in US$) in Malawi and Trade (in US$) in Yemen, Rep.?
Offer a very short reply. -2.07e+09. In the year 1999, what is the difference between the Trade (in US$) in Mozambique and Trade (in US$) in Yemen, Rep.?
Your answer should be compact. -7.44e+08. In the year 2000, what is the difference between the Trade (in US$) in Lower middle income and Trade (in US$) in Malawi?
Ensure brevity in your answer.  3.35e+11. In the year 2000, what is the difference between the Trade (in US$) in Lower middle income and Trade (in US$) in Mozambique?
Give a very brief answer. 3.34e+11. In the year 2000, what is the difference between the Trade (in US$) in Lower middle income and Trade (in US$) in Yemen, Rep.?
Offer a terse response. 3.33e+11. In the year 2000, what is the difference between the Trade (in US$) of Malawi and Trade (in US$) of Mozambique?
Provide a short and direct response. -1.37e+09. In the year 2000, what is the difference between the Trade (in US$) in Malawi and Trade (in US$) in Yemen, Rep.?
Make the answer very short. -2.66e+09. In the year 2000, what is the difference between the Trade (in US$) in Mozambique and Trade (in US$) in Yemen, Rep.?
Provide a short and direct response. -1.29e+09. In the year 2001, what is the difference between the Trade (in US$) of Lower middle income and Trade (in US$) of Malawi?
Offer a very short reply. 3.45e+11. In the year 2001, what is the difference between the Trade (in US$) of Lower middle income and Trade (in US$) of Mozambique?
Keep it short and to the point. 3.44e+11. In the year 2001, what is the difference between the Trade (in US$) of Lower middle income and Trade (in US$) of Yemen, Rep.?
Make the answer very short. 3.42e+11. In the year 2001, what is the difference between the Trade (in US$) in Malawi and Trade (in US$) in Mozambique?
Make the answer very short. -9.63e+08. In the year 2001, what is the difference between the Trade (in US$) of Malawi and Trade (in US$) of Yemen, Rep.?
Make the answer very short. -2.78e+09. In the year 2001, what is the difference between the Trade (in US$) in Mozambique and Trade (in US$) in Yemen, Rep.?
Give a very brief answer. -1.81e+09. In the year 2002, what is the difference between the Trade (in US$) in Lower middle income and Trade (in US$) in Malawi?
Give a very brief answer. 3.71e+11. In the year 2002, what is the difference between the Trade (in US$) of Lower middle income and Trade (in US$) of Mozambique?
Provide a succinct answer. 3.69e+11. In the year 2002, what is the difference between the Trade (in US$) in Lower middle income and Trade (in US$) in Yemen, Rep.?
Ensure brevity in your answer.  3.68e+11. In the year 2002, what is the difference between the Trade (in US$) in Malawi and Trade (in US$) in Mozambique?
Give a very brief answer. -1.91e+09. In the year 2002, what is the difference between the Trade (in US$) of Malawi and Trade (in US$) of Yemen, Rep.?
Provide a succinct answer. -3.12e+09. In the year 2002, what is the difference between the Trade (in US$) of Mozambique and Trade (in US$) of Yemen, Rep.?
Offer a terse response. -1.22e+09. In the year 2003, what is the difference between the Trade (in US$) of Lower middle income and Trade (in US$) of Malawi?
Offer a very short reply. 4.27e+11. In the year 2003, what is the difference between the Trade (in US$) of Lower middle income and Trade (in US$) of Mozambique?
Your response must be concise. 4.26e+11. In the year 2003, what is the difference between the Trade (in US$) of Lower middle income and Trade (in US$) of Yemen, Rep.?
Keep it short and to the point. 4.24e+11. In the year 2003, what is the difference between the Trade (in US$) in Malawi and Trade (in US$) in Mozambique?
Your answer should be compact. -1.87e+09. In the year 2003, what is the difference between the Trade (in US$) in Malawi and Trade (in US$) in Yemen, Rep.?
Offer a very short reply. -3.48e+09. In the year 2003, what is the difference between the Trade (in US$) in Mozambique and Trade (in US$) in Yemen, Rep.?
Ensure brevity in your answer.  -1.62e+09. What is the ratio of the Trade (in US$) in Lower middle income in 1996 to that in 1997?
Keep it short and to the point. 0.93. What is the ratio of the Trade (in US$) in Malawi in 1996 to that in 1997?
Your answer should be compact. 0.81. What is the ratio of the Trade (in US$) of Mozambique in 1996 to that in 1997?
Your answer should be very brief. 0.99. What is the ratio of the Trade (in US$) of Yemen, Rep. in 1996 to that in 1997?
Give a very brief answer. 0.89. What is the ratio of the Trade (in US$) of Lower middle income in 1996 to that in 1998?
Your response must be concise. 1.01. What is the ratio of the Trade (in US$) in Malawi in 1996 to that in 1998?
Provide a succinct answer. 1.09. What is the ratio of the Trade (in US$) in Mozambique in 1996 to that in 1998?
Offer a terse response. 0.97. What is the ratio of the Trade (in US$) in Yemen, Rep. in 1996 to that in 1998?
Your answer should be very brief. 0.92. What is the ratio of the Trade (in US$) of Lower middle income in 1996 to that in 1999?
Give a very brief answer. 1.01. What is the ratio of the Trade (in US$) of Malawi in 1996 to that in 1999?
Your answer should be very brief. 0.95. What is the ratio of the Trade (in US$) of Mozambique in 1996 to that in 1999?
Offer a very short reply. 0.68. What is the ratio of the Trade (in US$) in Yemen, Rep. in 1996 to that in 1999?
Make the answer very short. 0.97. What is the ratio of the Trade (in US$) of Lower middle income in 1996 to that in 2000?
Offer a terse response. 0.91. What is the ratio of the Trade (in US$) of Malawi in 1996 to that in 2000?
Make the answer very short. 1.18. What is the ratio of the Trade (in US$) of Mozambique in 1996 to that in 2000?
Your response must be concise. 0.72. What is the ratio of the Trade (in US$) of Yemen, Rep. in 1996 to that in 2000?
Make the answer very short. 0.84. What is the ratio of the Trade (in US$) in Lower middle income in 1996 to that in 2001?
Make the answer very short. 0.89. What is the ratio of the Trade (in US$) of Malawi in 1996 to that in 2001?
Your response must be concise. 1.08. What is the ratio of the Trade (in US$) in Mozambique in 1996 to that in 2001?
Offer a terse response. 0.87. What is the ratio of the Trade (in US$) in Yemen, Rep. in 1996 to that in 2001?
Make the answer very short. 0.8. What is the ratio of the Trade (in US$) of Lower middle income in 1996 to that in 2002?
Offer a terse response. 0.83. What is the ratio of the Trade (in US$) in Malawi in 1996 to that in 2002?
Offer a very short reply. 0.8. What is the ratio of the Trade (in US$) of Mozambique in 1996 to that in 2002?
Your answer should be very brief. 0.51. What is the ratio of the Trade (in US$) of Yemen, Rep. in 1996 to that in 2002?
Provide a succinct answer. 0.68. What is the ratio of the Trade (in US$) of Lower middle income in 1996 to that in 2003?
Ensure brevity in your answer.  0.72. What is the ratio of the Trade (in US$) in Malawi in 1996 to that in 2003?
Offer a terse response. 0.74. What is the ratio of the Trade (in US$) of Mozambique in 1996 to that in 2003?
Offer a terse response. 0.5. What is the ratio of the Trade (in US$) of Yemen, Rep. in 1996 to that in 2003?
Provide a short and direct response. 0.61. What is the ratio of the Trade (in US$) in Lower middle income in 1997 to that in 1998?
Keep it short and to the point. 1.09. What is the ratio of the Trade (in US$) of Malawi in 1997 to that in 1998?
Offer a very short reply. 1.34. What is the ratio of the Trade (in US$) of Mozambique in 1997 to that in 1998?
Make the answer very short. 0.98. What is the ratio of the Trade (in US$) of Yemen, Rep. in 1997 to that in 1998?
Offer a very short reply. 1.03. What is the ratio of the Trade (in US$) in Lower middle income in 1997 to that in 1999?
Provide a short and direct response. 1.09. What is the ratio of the Trade (in US$) of Malawi in 1997 to that in 1999?
Offer a very short reply. 1.16. What is the ratio of the Trade (in US$) of Mozambique in 1997 to that in 1999?
Offer a terse response. 0.69. What is the ratio of the Trade (in US$) of Yemen, Rep. in 1997 to that in 1999?
Offer a very short reply. 1.09. What is the ratio of the Trade (in US$) of Lower middle income in 1997 to that in 2000?
Your answer should be compact. 0.98. What is the ratio of the Trade (in US$) of Malawi in 1997 to that in 2000?
Make the answer very short. 1.45. What is the ratio of the Trade (in US$) of Mozambique in 1997 to that in 2000?
Your answer should be very brief. 0.73. What is the ratio of the Trade (in US$) in Yemen, Rep. in 1997 to that in 2000?
Give a very brief answer. 0.94. What is the ratio of the Trade (in US$) of Lower middle income in 1997 to that in 2001?
Your answer should be compact. 0.96. What is the ratio of the Trade (in US$) in Malawi in 1997 to that in 2001?
Your response must be concise. 1.33. What is the ratio of the Trade (in US$) of Mozambique in 1997 to that in 2001?
Make the answer very short. 0.88. What is the ratio of the Trade (in US$) of Yemen, Rep. in 1997 to that in 2001?
Offer a terse response. 0.89. What is the ratio of the Trade (in US$) in Lower middle income in 1997 to that in 2002?
Your response must be concise. 0.89. What is the ratio of the Trade (in US$) of Malawi in 1997 to that in 2002?
Offer a very short reply. 0.98. What is the ratio of the Trade (in US$) of Mozambique in 1997 to that in 2002?
Your response must be concise. 0.51. What is the ratio of the Trade (in US$) of Yemen, Rep. in 1997 to that in 2002?
Your answer should be very brief. 0.76. What is the ratio of the Trade (in US$) of Lower middle income in 1997 to that in 2003?
Provide a short and direct response. 0.77. What is the ratio of the Trade (in US$) of Malawi in 1997 to that in 2003?
Make the answer very short. 0.91. What is the ratio of the Trade (in US$) in Mozambique in 1997 to that in 2003?
Ensure brevity in your answer.  0.51. What is the ratio of the Trade (in US$) of Yemen, Rep. in 1997 to that in 2003?
Offer a terse response. 0.69. What is the ratio of the Trade (in US$) of Malawi in 1998 to that in 1999?
Give a very brief answer. 0.87. What is the ratio of the Trade (in US$) of Mozambique in 1998 to that in 1999?
Keep it short and to the point. 0.7. What is the ratio of the Trade (in US$) in Yemen, Rep. in 1998 to that in 1999?
Keep it short and to the point. 1.05. What is the ratio of the Trade (in US$) of Lower middle income in 1998 to that in 2000?
Provide a short and direct response. 0.9. What is the ratio of the Trade (in US$) in Malawi in 1998 to that in 2000?
Make the answer very short. 1.08. What is the ratio of the Trade (in US$) of Mozambique in 1998 to that in 2000?
Provide a short and direct response. 0.74. What is the ratio of the Trade (in US$) in Yemen, Rep. in 1998 to that in 2000?
Offer a terse response. 0.91. What is the ratio of the Trade (in US$) of Lower middle income in 1998 to that in 2001?
Your answer should be compact. 0.88. What is the ratio of the Trade (in US$) of Mozambique in 1998 to that in 2001?
Give a very brief answer. 0.9. What is the ratio of the Trade (in US$) of Yemen, Rep. in 1998 to that in 2001?
Offer a terse response. 0.87. What is the ratio of the Trade (in US$) of Lower middle income in 1998 to that in 2002?
Ensure brevity in your answer.  0.81. What is the ratio of the Trade (in US$) of Malawi in 1998 to that in 2002?
Offer a terse response. 0.73. What is the ratio of the Trade (in US$) in Mozambique in 1998 to that in 2002?
Provide a short and direct response. 0.52. What is the ratio of the Trade (in US$) of Yemen, Rep. in 1998 to that in 2002?
Your answer should be compact. 0.74. What is the ratio of the Trade (in US$) in Lower middle income in 1998 to that in 2003?
Make the answer very short. 0.71. What is the ratio of the Trade (in US$) in Malawi in 1998 to that in 2003?
Keep it short and to the point. 0.68. What is the ratio of the Trade (in US$) of Mozambique in 1998 to that in 2003?
Keep it short and to the point. 0.52. What is the ratio of the Trade (in US$) in Yemen, Rep. in 1998 to that in 2003?
Make the answer very short. 0.67. What is the ratio of the Trade (in US$) in Lower middle income in 1999 to that in 2000?
Offer a terse response. 0.9. What is the ratio of the Trade (in US$) in Malawi in 1999 to that in 2000?
Give a very brief answer. 1.25. What is the ratio of the Trade (in US$) in Mozambique in 1999 to that in 2000?
Your response must be concise. 1.06. What is the ratio of the Trade (in US$) in Yemen, Rep. in 1999 to that in 2000?
Ensure brevity in your answer.  0.87. What is the ratio of the Trade (in US$) of Lower middle income in 1999 to that in 2001?
Offer a very short reply. 0.88. What is the ratio of the Trade (in US$) of Malawi in 1999 to that in 2001?
Make the answer very short. 1.14. What is the ratio of the Trade (in US$) in Mozambique in 1999 to that in 2001?
Provide a succinct answer. 1.28. What is the ratio of the Trade (in US$) in Yemen, Rep. in 1999 to that in 2001?
Provide a short and direct response. 0.82. What is the ratio of the Trade (in US$) in Lower middle income in 1999 to that in 2002?
Keep it short and to the point. 0.82. What is the ratio of the Trade (in US$) of Malawi in 1999 to that in 2002?
Offer a very short reply. 0.84. What is the ratio of the Trade (in US$) of Mozambique in 1999 to that in 2002?
Keep it short and to the point. 0.74. What is the ratio of the Trade (in US$) of Yemen, Rep. in 1999 to that in 2002?
Offer a very short reply. 0.7. What is the ratio of the Trade (in US$) of Lower middle income in 1999 to that in 2003?
Offer a very short reply. 0.71. What is the ratio of the Trade (in US$) of Malawi in 1999 to that in 2003?
Keep it short and to the point. 0.78. What is the ratio of the Trade (in US$) of Mozambique in 1999 to that in 2003?
Provide a short and direct response. 0.73. What is the ratio of the Trade (in US$) of Yemen, Rep. in 1999 to that in 2003?
Your answer should be very brief. 0.64. What is the ratio of the Trade (in US$) of Lower middle income in 2000 to that in 2001?
Give a very brief answer. 0.97. What is the ratio of the Trade (in US$) of Malawi in 2000 to that in 2001?
Offer a terse response. 0.92. What is the ratio of the Trade (in US$) in Mozambique in 2000 to that in 2001?
Give a very brief answer. 1.21. What is the ratio of the Trade (in US$) of Yemen, Rep. in 2000 to that in 2001?
Your answer should be very brief. 0.95. What is the ratio of the Trade (in US$) of Lower middle income in 2000 to that in 2002?
Make the answer very short. 0.9. What is the ratio of the Trade (in US$) of Malawi in 2000 to that in 2002?
Make the answer very short. 0.68. What is the ratio of the Trade (in US$) of Mozambique in 2000 to that in 2002?
Offer a very short reply. 0.7. What is the ratio of the Trade (in US$) in Yemen, Rep. in 2000 to that in 2002?
Keep it short and to the point. 0.81. What is the ratio of the Trade (in US$) of Lower middle income in 2000 to that in 2003?
Offer a terse response. 0.78. What is the ratio of the Trade (in US$) of Malawi in 2000 to that in 2003?
Give a very brief answer. 0.63. What is the ratio of the Trade (in US$) of Mozambique in 2000 to that in 2003?
Keep it short and to the point. 0.7. What is the ratio of the Trade (in US$) in Yemen, Rep. in 2000 to that in 2003?
Your response must be concise. 0.73. What is the ratio of the Trade (in US$) of Lower middle income in 2001 to that in 2002?
Your answer should be very brief. 0.93. What is the ratio of the Trade (in US$) in Malawi in 2001 to that in 2002?
Offer a terse response. 0.74. What is the ratio of the Trade (in US$) of Mozambique in 2001 to that in 2002?
Your response must be concise. 0.58. What is the ratio of the Trade (in US$) of Yemen, Rep. in 2001 to that in 2002?
Offer a very short reply. 0.85. What is the ratio of the Trade (in US$) of Lower middle income in 2001 to that in 2003?
Keep it short and to the point. 0.81. What is the ratio of the Trade (in US$) in Malawi in 2001 to that in 2003?
Your response must be concise. 0.68. What is the ratio of the Trade (in US$) in Mozambique in 2001 to that in 2003?
Give a very brief answer. 0.57. What is the ratio of the Trade (in US$) in Yemen, Rep. in 2001 to that in 2003?
Keep it short and to the point. 0.77. What is the ratio of the Trade (in US$) of Lower middle income in 2002 to that in 2003?
Provide a succinct answer. 0.87. What is the ratio of the Trade (in US$) in Malawi in 2002 to that in 2003?
Your response must be concise. 0.92. What is the ratio of the Trade (in US$) of Yemen, Rep. in 2002 to that in 2003?
Offer a terse response. 0.9. What is the difference between the highest and the second highest Trade (in US$) in Lower middle income?
Your response must be concise. 5.64e+1. What is the difference between the highest and the second highest Trade (in US$) in Malawi?
Offer a terse response. 7.41e+07. What is the difference between the highest and the second highest Trade (in US$) of Mozambique?
Offer a very short reply. 3.37e+07. What is the difference between the highest and the second highest Trade (in US$) in Yemen, Rep.?
Offer a very short reply. 4.34e+08. What is the difference between the highest and the lowest Trade (in US$) in Lower middle income?
Give a very brief answer. 1.26e+11. What is the difference between the highest and the lowest Trade (in US$) in Malawi?
Offer a terse response. 3.68e+08. What is the difference between the highest and the lowest Trade (in US$) in Mozambique?
Your answer should be very brief. 1.42e+09. What is the difference between the highest and the lowest Trade (in US$) in Yemen, Rep.?
Offer a terse response. 1.72e+09. 